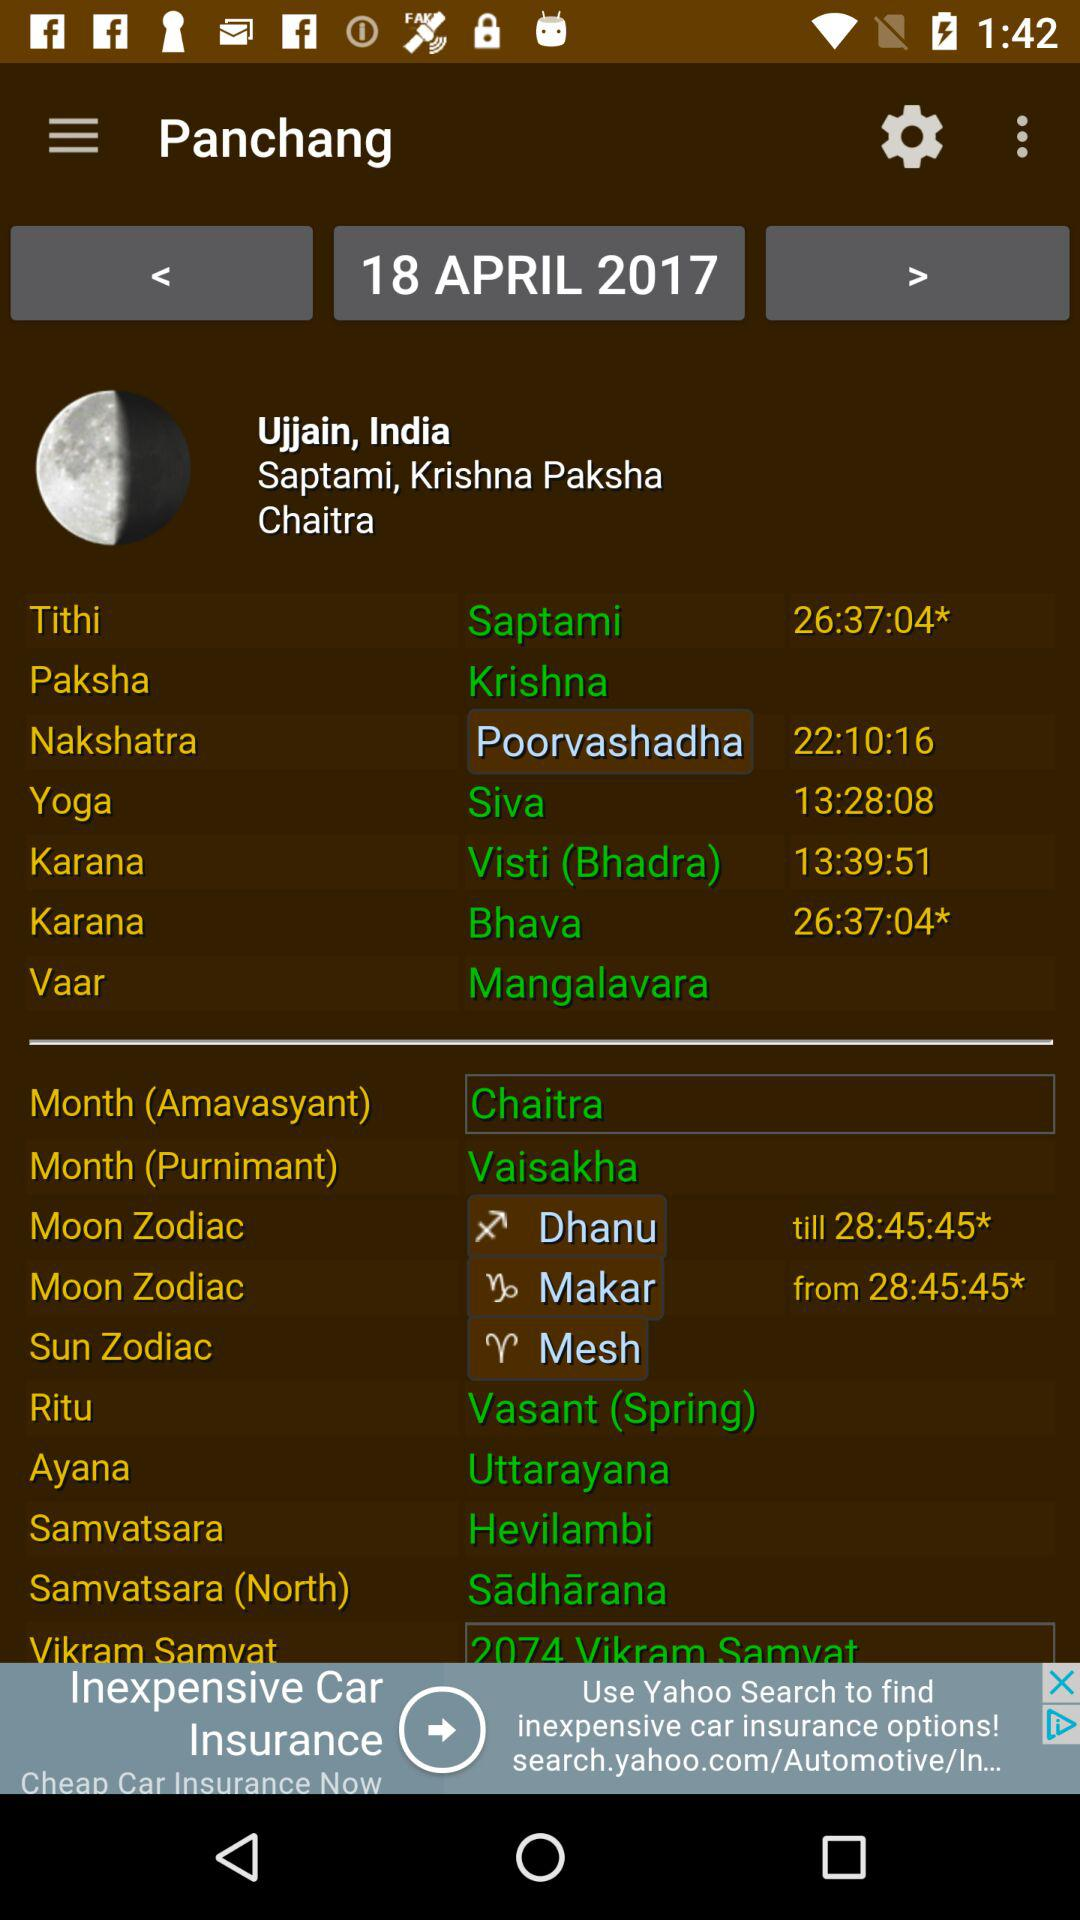What is the "Ritu"? The "Ritu" is Vasant (spring). 